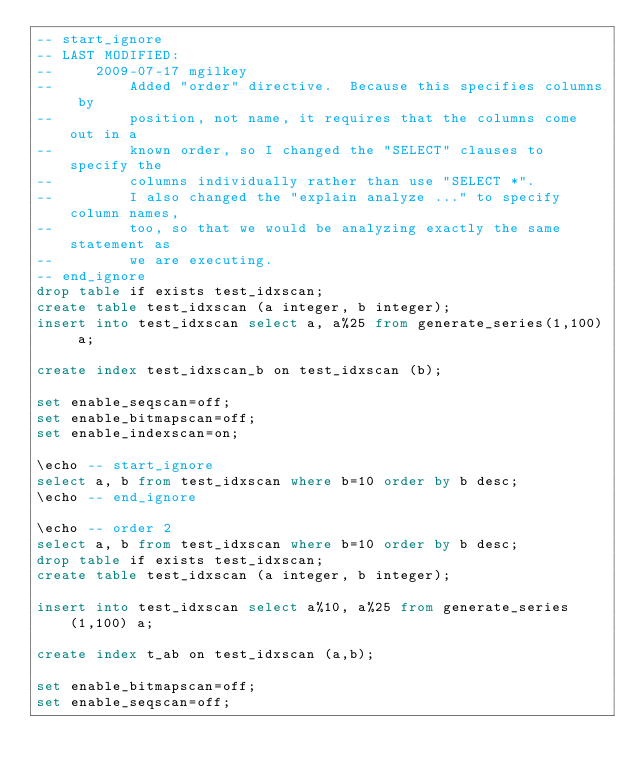<code> <loc_0><loc_0><loc_500><loc_500><_SQL_>-- start_ignore
-- LAST MODIFIED:
--     2009-07-17 mgilkey
--         Added "order" directive.  Because this specifies columns by
--         position, not name, it requires that the columns come out in a
--         known order, so I changed the "SELECT" clauses to specify the
--         columns individually rather than use "SELECT *".
--         I also changed the "explain analyze ..." to specify column names, 
--         too, so that we would be analyzing exactly the same statement as 
--         we are executing.
-- end_ignore
drop table if exists test_idxscan;
create table test_idxscan (a integer, b integer);
insert into test_idxscan select a, a%25 from generate_series(1,100) a;

create index test_idxscan_b on test_idxscan (b);

set enable_seqscan=off;
set enable_bitmapscan=off;
set enable_indexscan=on;

\echo -- start_ignore
select a, b from test_idxscan where b=10 order by b desc;
\echo -- end_ignore

\echo -- order 2
select a, b from test_idxscan where b=10 order by b desc;
drop table if exists test_idxscan;
create table test_idxscan (a integer, b integer);

insert into test_idxscan select a%10, a%25 from generate_series(1,100) a;

create index t_ab on test_idxscan (a,b);

set enable_bitmapscan=off;
set enable_seqscan=off;</code> 